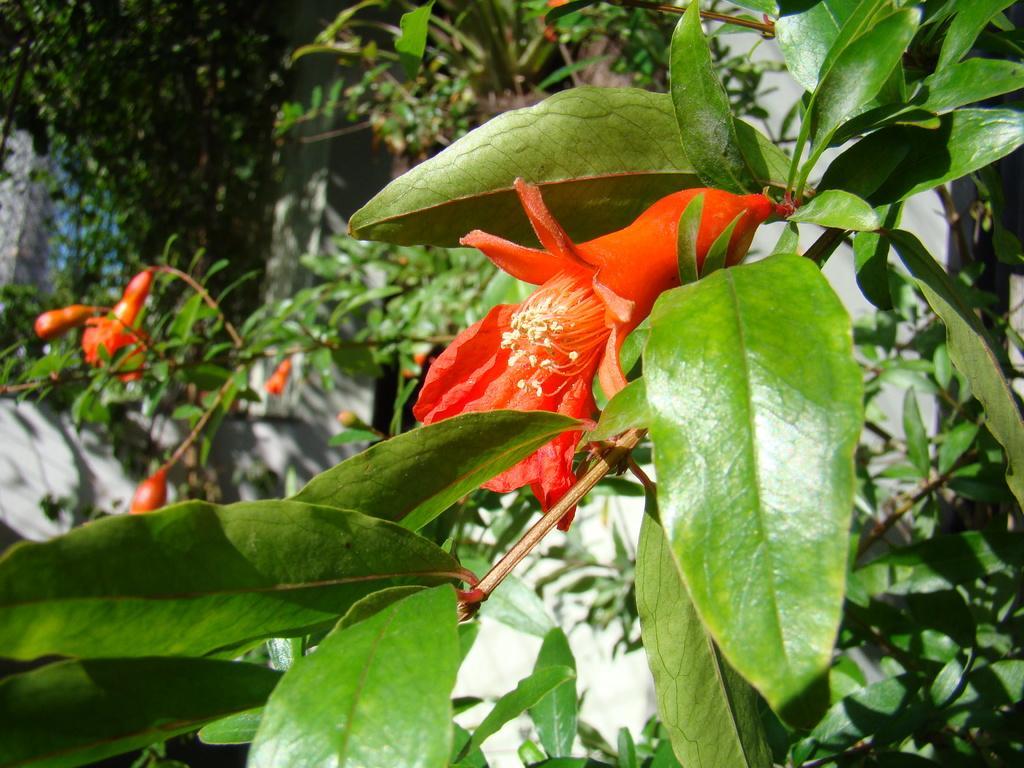How would you summarize this image in a sentence or two? In this image we can see a pomegranate tree with flowers. 